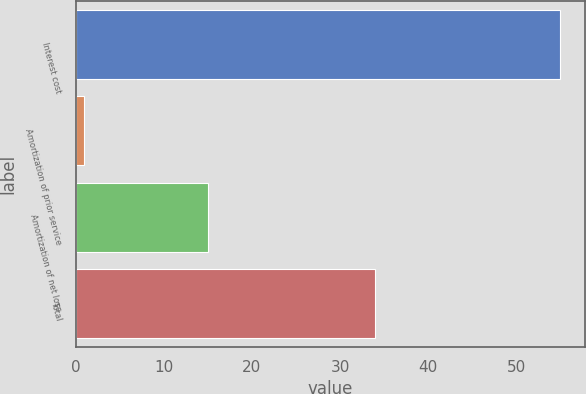Convert chart. <chart><loc_0><loc_0><loc_500><loc_500><bar_chart><fcel>Interest cost<fcel>Amortization of prior service<fcel>Amortization of net loss<fcel>Total<nl><fcel>55<fcel>1<fcel>15<fcel>34<nl></chart> 